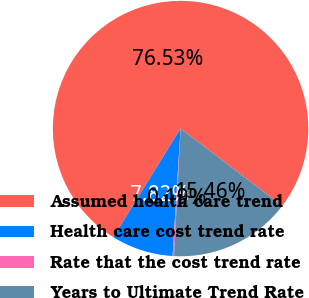Convert chart. <chart><loc_0><loc_0><loc_500><loc_500><pie_chart><fcel>Assumed health care trend<fcel>Health care cost trend rate<fcel>Rate that the cost trend rate<fcel>Years to Ultimate Trend Rate<nl><fcel>76.53%<fcel>7.82%<fcel>0.19%<fcel>15.46%<nl></chart> 